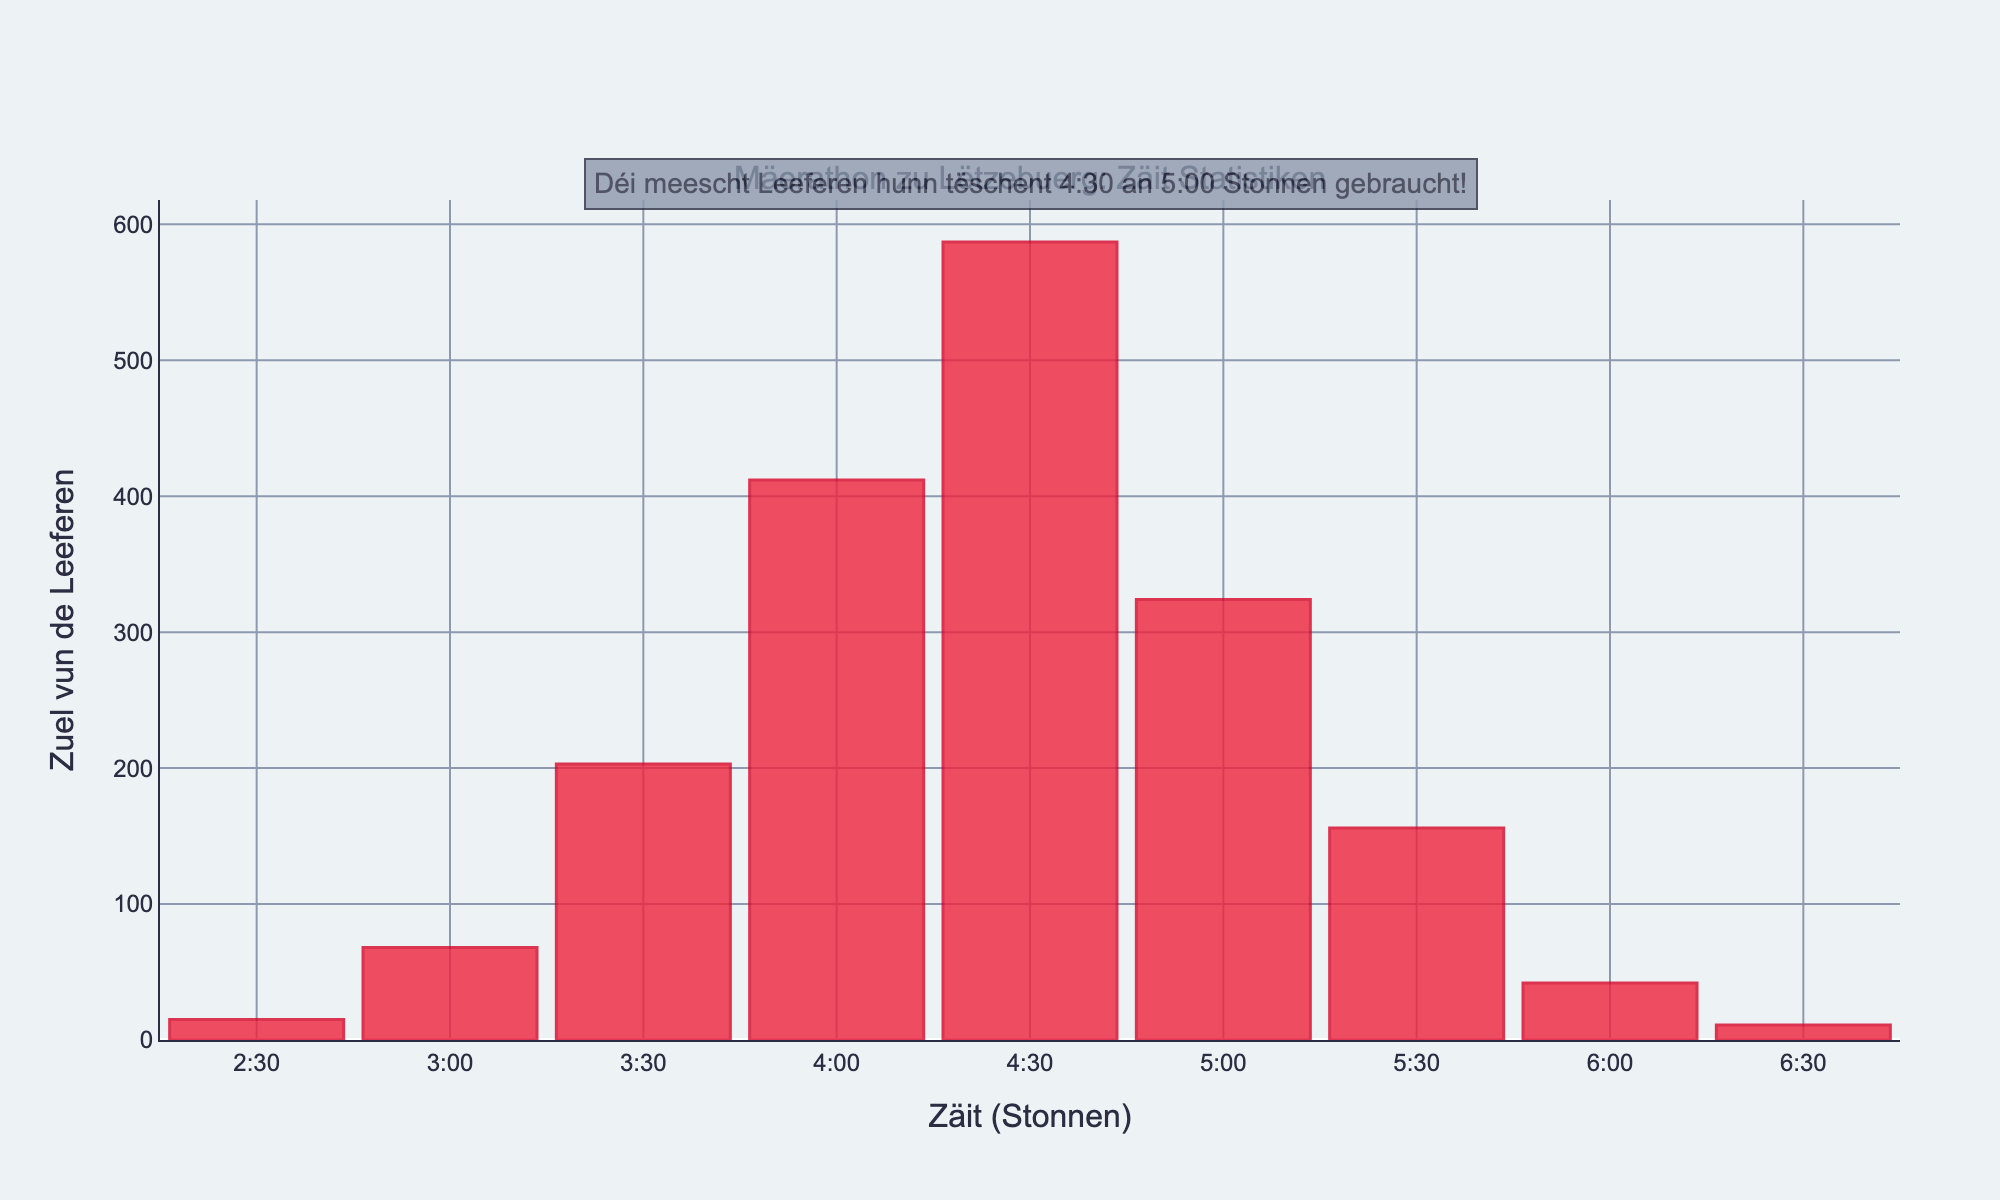What is the title of the plot? The title of the plot is located at the top of the figure. It reads as "Mäerathon zu Lëtzebuerg: Zäit Statistiken".
Answer: Mäerathon zu Lëtzebuerg: Zäit Statistiken Which time range had the highest number of runners? To identify the time range with the highest number of runners, look for the tallest bar in the histogram. The tallest bar corresponds to the finishing time range of 4:30:00 - 4:59:59 with 587 runners.
Answer: 4:30:00 - 4:59:59 How many runners finished between 3:00:00 and 3:59:59? To find the total number of runners for this duration, sum the values of runners from both the 3:00:00 - 3:29:59 and 3:30:00 - 3:59:59 time ranges. The counts are 68 and 203 respectively. Adding them gives 68 + 203 = 271.
Answer: 271 What is the color of the bars in the histogram? The bar colors in the histogram are red with a slightly darker red outline.
Answer: Red What is the total number of runners who finished the marathon? To find the total number of runners, sum the number of runners from all the time ranges: 15 + 68 + 203 + 412 + 587 + 324 + 156 + 42 + 11. This equals 1818 in total.
Answer: 1818 Which time range had the lowest number of runners? Identify the shortest bar in the histogram, which corresponds to the time range with the smallest number of runners. The shortest bar represents the 6:30:00 - 6:59:59 range with 11 runners.
Answer: 6:30:00 - 6:59:59 How does the number of runners between 4:00:00 and 4:29:59 compare to those between 5:00 and 5:29:59? Compare the heights of the bars corresponding to these two time ranges. The bar for 4:00:00 - 4:29:59 has 412 runners, whereas the bar for 5:00:00 - 5:29:59 has 324 runners. 412 is greater than 324.
Answer: Greater Between which two consecutive time ranges is the largest difference in the number of runners? Calculate the differences in the number of runners between each pair of consecutive time ranges and identify the largest value. The largest difference is between the 4:30:00 - 4:59:59 range (587 runners) and the 5:00:00 - 5:29:59 range (324 runners), with a difference of 587 - 324 = 263 runners.
Answer: 4:30:00 - 4:59:59 and 5:00:00 - 5:29:59 Which time range has the midpoint labeled '5:30'? Check the x-axis labels to find the 5:30 mark, then match it to the corresponding time range in the histogram. The time range with the midpoint labeled 5:30 is 5:30:00 - 5:59:59.
Answer: 5:30:00 - 5:59:59 What is the duration most runners took to finish? Look for the annotation highlighting the statement about the most common time range where runners finished. It states that most runners took between 4:30 and 5:00 hours.
Answer: 4:30 - 5:00 hours 